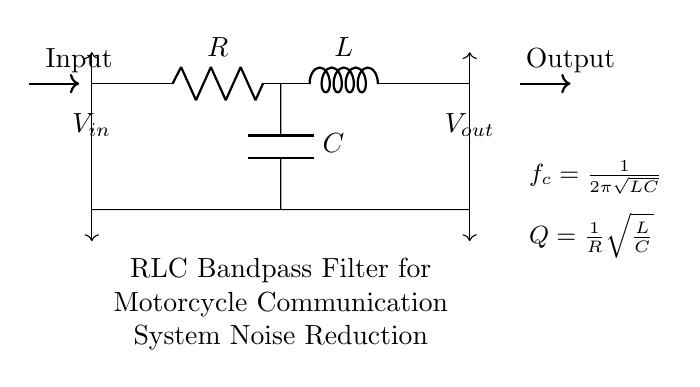What type of filter is represented in this circuit? The circuit is labeled as an RLC Bandpass Filter, which indicates that it is designed to allow certain frequencies to pass while attenuating others.
Answer: RLC Bandpass Filter What are the components used in this circuit? The circuit diagram includes three primary components: a resistor, an inductor, and a capacitor, as denoted by R, L, and C respectively.
Answer: Resistor, Inductor, Capacitor What is the formula for the cut-off frequency? The diagram provides the formula for the cut-off frequency as \(f_c = \frac{1}{2\pi\sqrt{LC}}\), which is specifically for RLC filters.
Answer: \(f_c = \frac{1}{2\pi\sqrt{LC}}\) How does the quality factor (Q) relate to the resistor in this circuit? The quality factor is defined in the circuit as \(Q = \frac{1}{R}\sqrt{\frac{L}{C}}\), indicating that Q is inversely proportional to R, and is affected by L and C values.
Answer: Inversely proportional to R What is the relationship between R, L, and C for achieving a higher Q factor? To achieve a higher Q factor, the resistance R must be lower relative to the values of L and C, as the formula shows R in the denominator.
Answer: Lower R values What would happen if the capacitor's value is increased in this circuit? Increasing the capacitor's value will lower the cut-off frequency \(f_c\), resulting in changing the range of frequencies that can pass through the filter, indicating a shift in its performance.
Answer: Lower cut-off frequency 